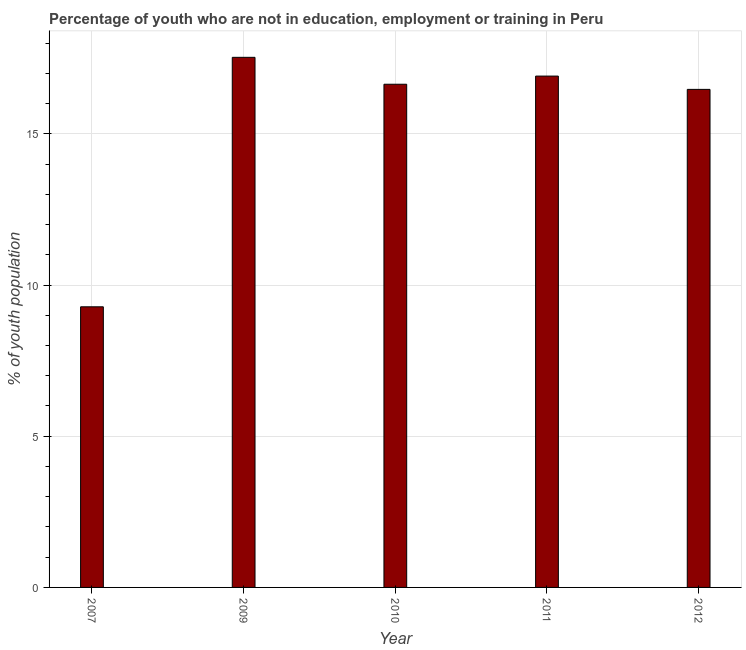What is the title of the graph?
Your answer should be very brief. Percentage of youth who are not in education, employment or training in Peru. What is the label or title of the Y-axis?
Your response must be concise. % of youth population. What is the unemployed youth population in 2009?
Your answer should be compact. 17.53. Across all years, what is the maximum unemployed youth population?
Provide a short and direct response. 17.53. Across all years, what is the minimum unemployed youth population?
Offer a terse response. 9.28. In which year was the unemployed youth population minimum?
Offer a very short reply. 2007. What is the sum of the unemployed youth population?
Your answer should be compact. 76.83. What is the difference between the unemployed youth population in 2010 and 2012?
Your response must be concise. 0.17. What is the average unemployed youth population per year?
Keep it short and to the point. 15.37. What is the median unemployed youth population?
Your answer should be very brief. 16.64. In how many years, is the unemployed youth population greater than 13 %?
Ensure brevity in your answer.  4. Do a majority of the years between 2007 and 2012 (inclusive) have unemployed youth population greater than 9 %?
Your response must be concise. Yes. What is the difference between the highest and the second highest unemployed youth population?
Your answer should be very brief. 0.62. Is the sum of the unemployed youth population in 2009 and 2011 greater than the maximum unemployed youth population across all years?
Make the answer very short. Yes. What is the difference between the highest and the lowest unemployed youth population?
Offer a terse response. 8.25. In how many years, is the unemployed youth population greater than the average unemployed youth population taken over all years?
Make the answer very short. 4. How many bars are there?
Your answer should be very brief. 5. Are all the bars in the graph horizontal?
Provide a short and direct response. No. What is the difference between two consecutive major ticks on the Y-axis?
Give a very brief answer. 5. Are the values on the major ticks of Y-axis written in scientific E-notation?
Offer a terse response. No. What is the % of youth population of 2007?
Provide a short and direct response. 9.28. What is the % of youth population in 2009?
Your answer should be compact. 17.53. What is the % of youth population of 2010?
Offer a very short reply. 16.64. What is the % of youth population of 2011?
Provide a short and direct response. 16.91. What is the % of youth population in 2012?
Offer a very short reply. 16.47. What is the difference between the % of youth population in 2007 and 2009?
Provide a short and direct response. -8.25. What is the difference between the % of youth population in 2007 and 2010?
Your answer should be very brief. -7.36. What is the difference between the % of youth population in 2007 and 2011?
Your answer should be very brief. -7.63. What is the difference between the % of youth population in 2007 and 2012?
Offer a very short reply. -7.19. What is the difference between the % of youth population in 2009 and 2010?
Your response must be concise. 0.89. What is the difference between the % of youth population in 2009 and 2011?
Provide a succinct answer. 0.62. What is the difference between the % of youth population in 2009 and 2012?
Your response must be concise. 1.06. What is the difference between the % of youth population in 2010 and 2011?
Ensure brevity in your answer.  -0.27. What is the difference between the % of youth population in 2010 and 2012?
Your answer should be very brief. 0.17. What is the difference between the % of youth population in 2011 and 2012?
Make the answer very short. 0.44. What is the ratio of the % of youth population in 2007 to that in 2009?
Offer a terse response. 0.53. What is the ratio of the % of youth population in 2007 to that in 2010?
Provide a short and direct response. 0.56. What is the ratio of the % of youth population in 2007 to that in 2011?
Provide a short and direct response. 0.55. What is the ratio of the % of youth population in 2007 to that in 2012?
Provide a short and direct response. 0.56. What is the ratio of the % of youth population in 2009 to that in 2010?
Ensure brevity in your answer.  1.05. What is the ratio of the % of youth population in 2009 to that in 2011?
Offer a terse response. 1.04. What is the ratio of the % of youth population in 2009 to that in 2012?
Give a very brief answer. 1.06. What is the ratio of the % of youth population in 2010 to that in 2012?
Your answer should be very brief. 1.01. 